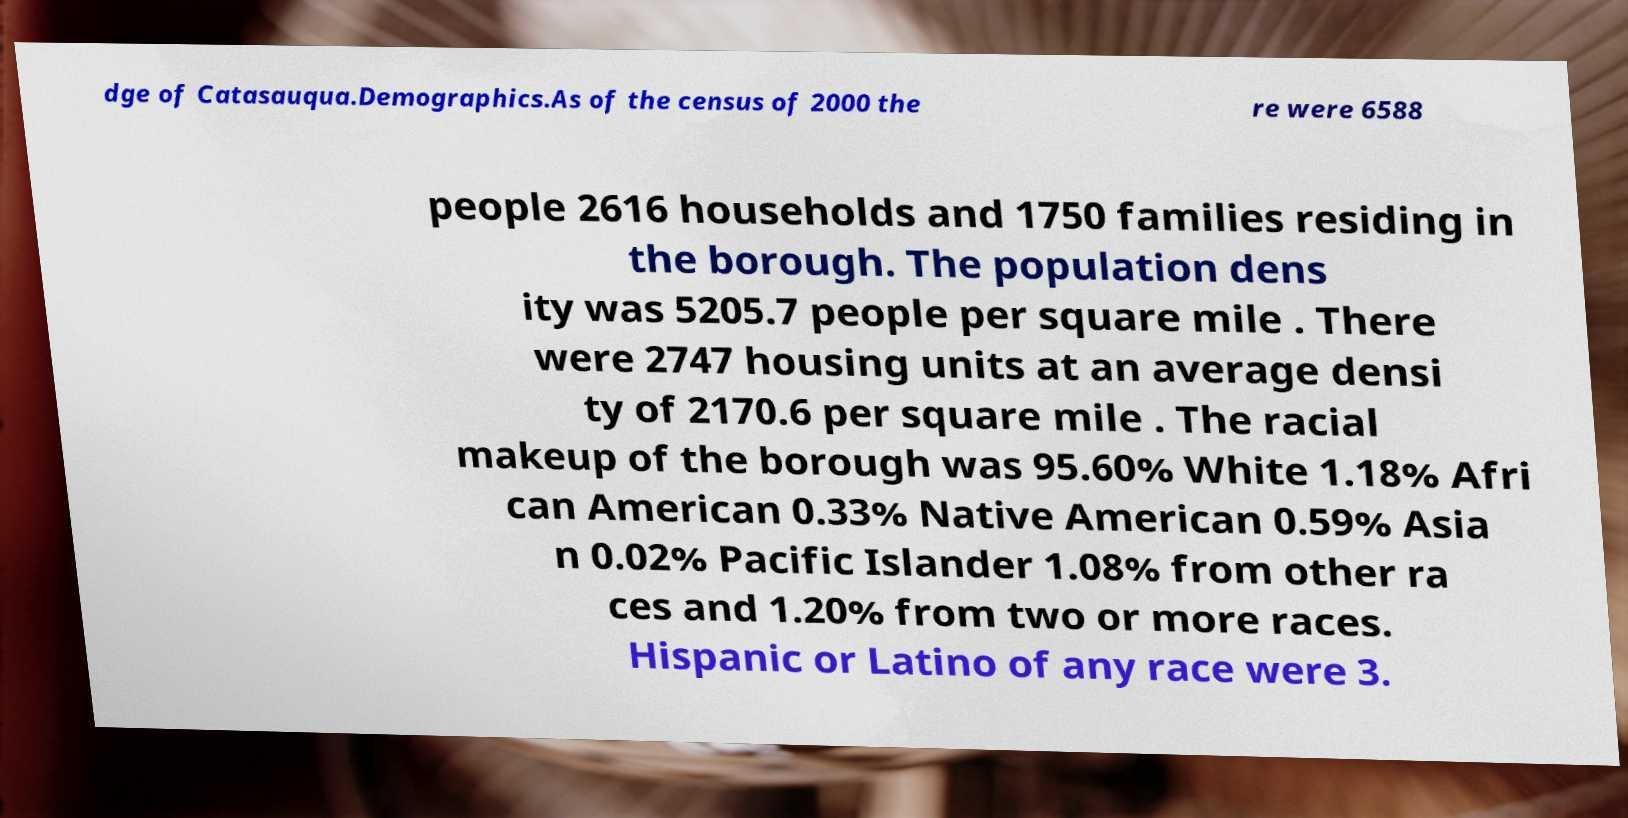What messages or text are displayed in this image? I need them in a readable, typed format. dge of Catasauqua.Demographics.As of the census of 2000 the re were 6588 people 2616 households and 1750 families residing in the borough. The population dens ity was 5205.7 people per square mile . There were 2747 housing units at an average densi ty of 2170.6 per square mile . The racial makeup of the borough was 95.60% White 1.18% Afri can American 0.33% Native American 0.59% Asia n 0.02% Pacific Islander 1.08% from other ra ces and 1.20% from two or more races. Hispanic or Latino of any race were 3. 